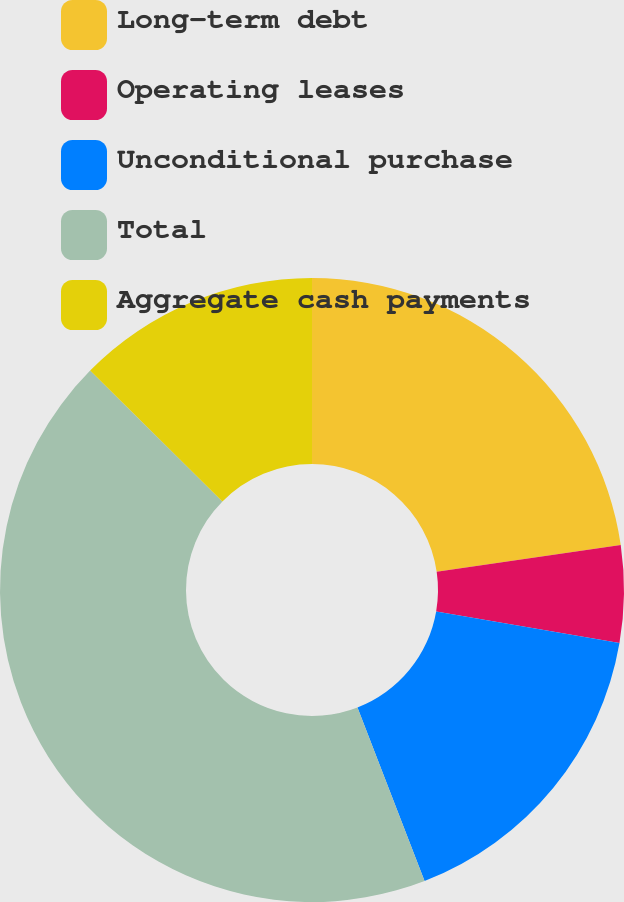Convert chart to OTSL. <chart><loc_0><loc_0><loc_500><loc_500><pie_chart><fcel>Long-term debt<fcel>Operating leases<fcel>Unconditional purchase<fcel>Total<fcel>Aggregate cash payments<nl><fcel>22.7%<fcel>5.02%<fcel>16.41%<fcel>43.29%<fcel>12.59%<nl></chart> 